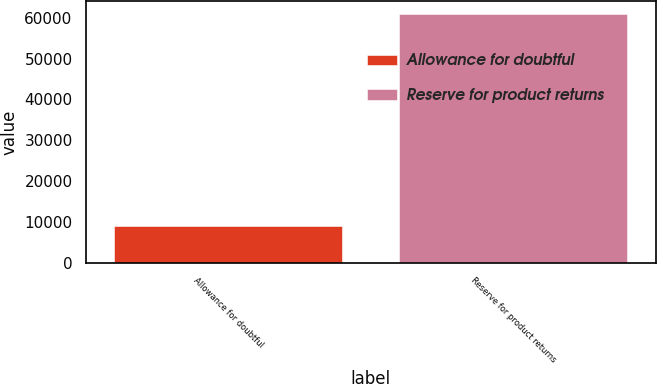Convert chart. <chart><loc_0><loc_0><loc_500><loc_500><bar_chart><fcel>Allowance for doubtful<fcel>Reserve for product returns<nl><fcel>9018<fcel>60979<nl></chart> 